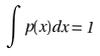Convert formula to latex. <formula><loc_0><loc_0><loc_500><loc_500>\int p ( x ) d x = 1</formula> 